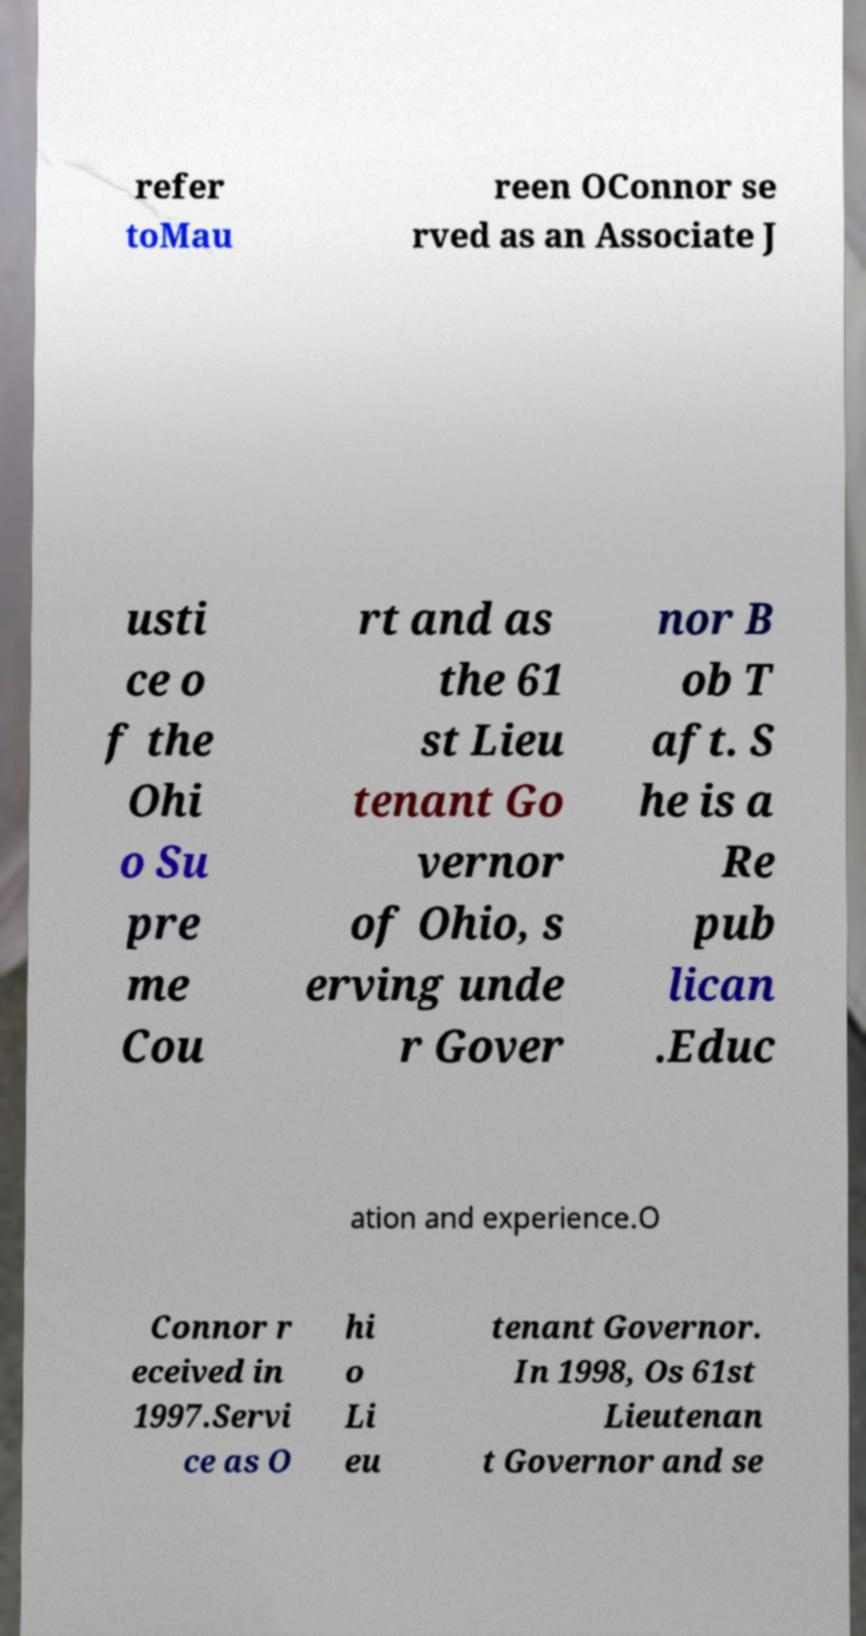I need the written content from this picture converted into text. Can you do that? refer toMau reen OConnor se rved as an Associate J usti ce o f the Ohi o Su pre me Cou rt and as the 61 st Lieu tenant Go vernor of Ohio, s erving unde r Gover nor B ob T aft. S he is a Re pub lican .Educ ation and experience.O Connor r eceived in 1997.Servi ce as O hi o Li eu tenant Governor. In 1998, Os 61st Lieutenan t Governor and se 